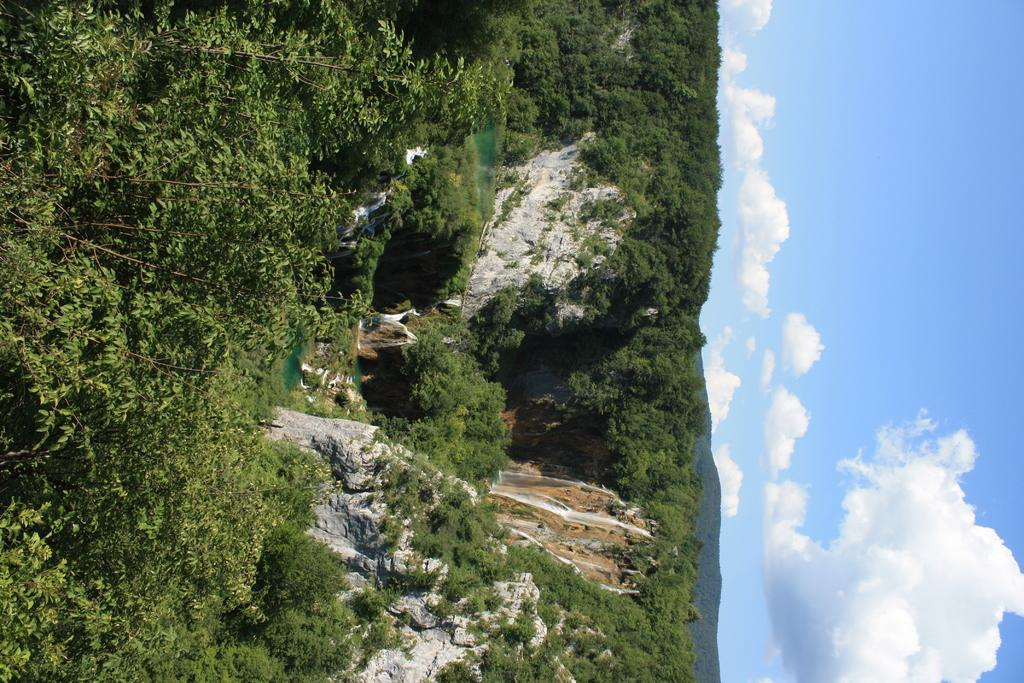What type of vegetation is at the bottom of the image? There are trees at the bottom of the image. What type of geographical feature is in the center of the image? There are mountains in the center of the image. What part of the natural environment is visible on the right side of the image? The sky is visible on the right side of the image. Where is the plough located in the image? There is no plough present in the image. What type of appliance can be seen in the market in the image? There is no market or appliance present in the image. 